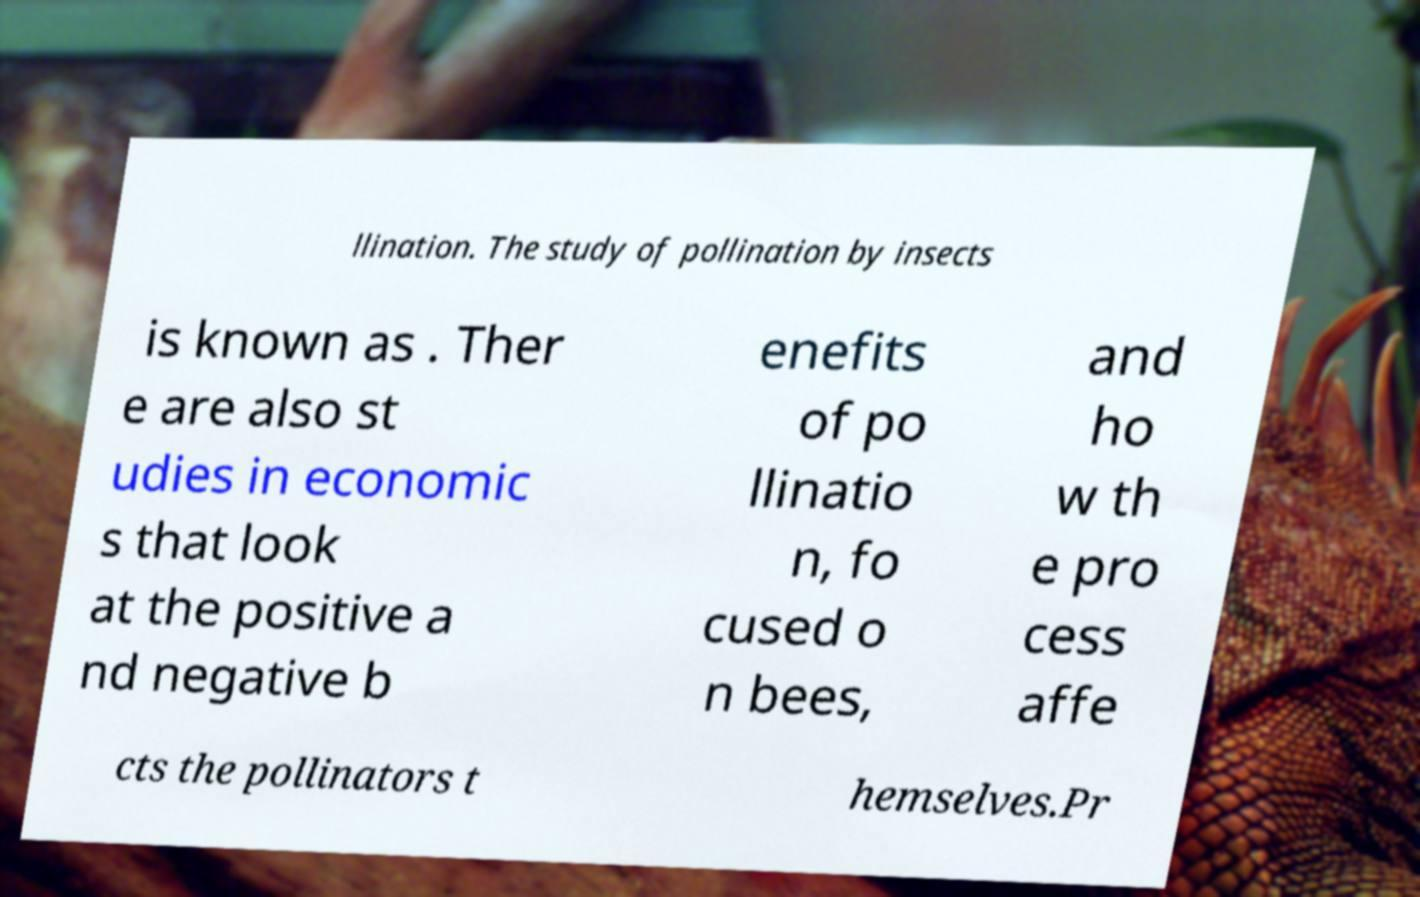There's text embedded in this image that I need extracted. Can you transcribe it verbatim? llination. The study of pollination by insects is known as . Ther e are also st udies in economic s that look at the positive a nd negative b enefits of po llinatio n, fo cused o n bees, and ho w th e pro cess affe cts the pollinators t hemselves.Pr 